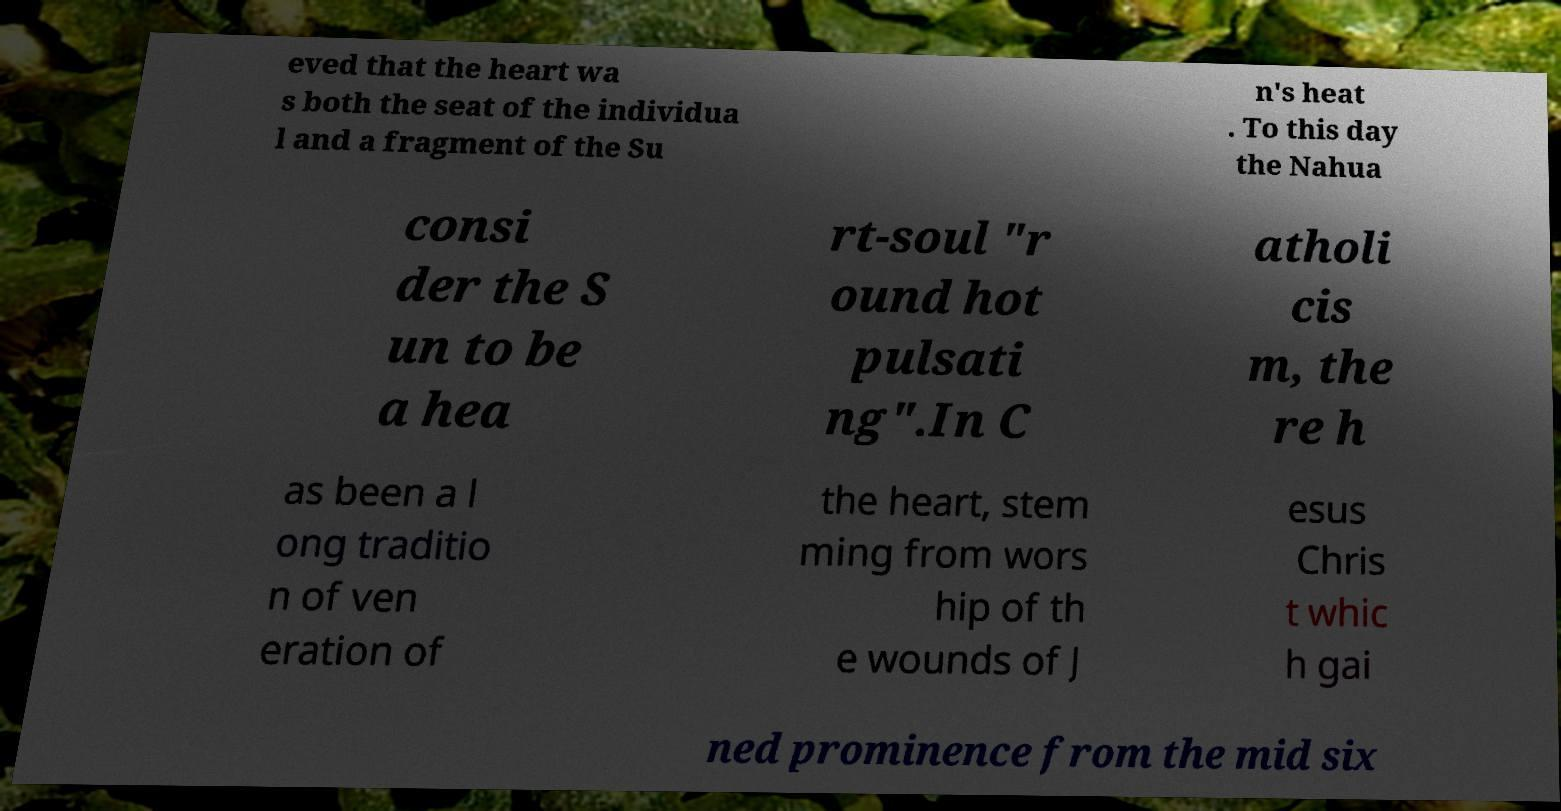What messages or text are displayed in this image? I need them in a readable, typed format. eved that the heart wa s both the seat of the individua l and a fragment of the Su n's heat . To this day the Nahua consi der the S un to be a hea rt-soul "r ound hot pulsati ng".In C atholi cis m, the re h as been a l ong traditio n of ven eration of the heart, stem ming from wors hip of th e wounds of J esus Chris t whic h gai ned prominence from the mid six 